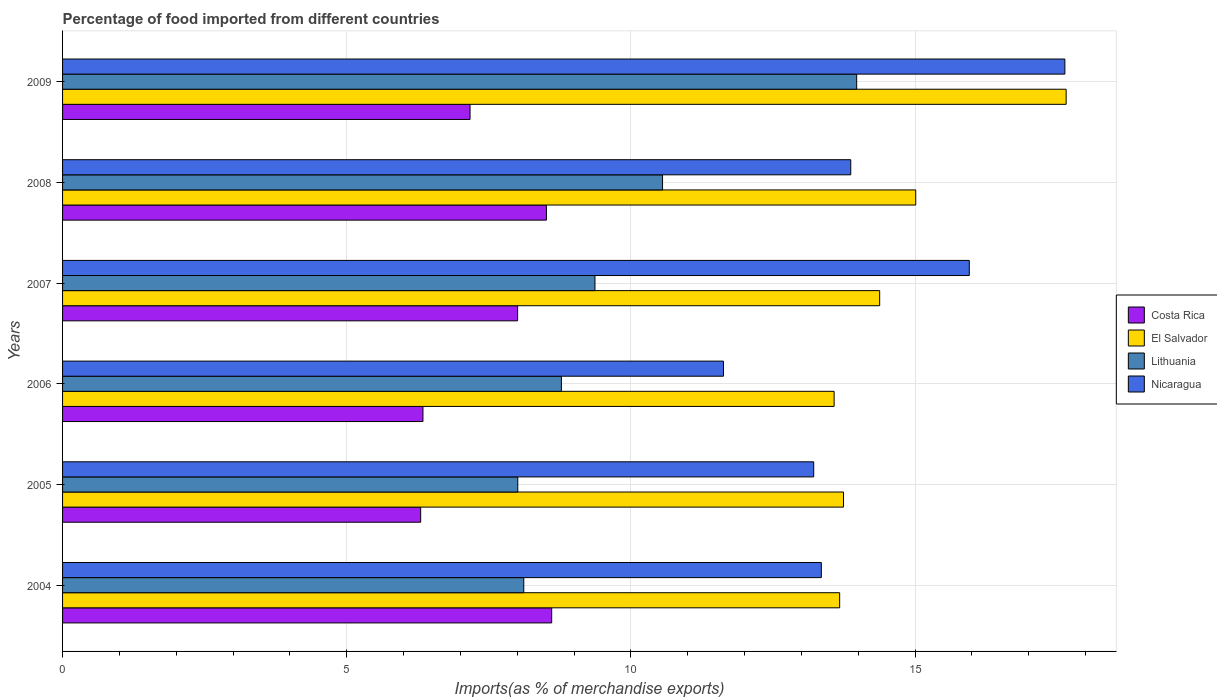Are the number of bars per tick equal to the number of legend labels?
Offer a very short reply. Yes. Are the number of bars on each tick of the Y-axis equal?
Offer a very short reply. Yes. How many bars are there on the 6th tick from the top?
Provide a succinct answer. 4. How many bars are there on the 1st tick from the bottom?
Offer a very short reply. 4. What is the percentage of imports to different countries in Costa Rica in 2008?
Make the answer very short. 8.51. Across all years, what is the maximum percentage of imports to different countries in Costa Rica?
Offer a terse response. 8.61. Across all years, what is the minimum percentage of imports to different countries in Lithuania?
Provide a short and direct response. 8.01. In which year was the percentage of imports to different countries in Lithuania minimum?
Keep it short and to the point. 2005. What is the total percentage of imports to different countries in Nicaragua in the graph?
Offer a terse response. 85.65. What is the difference between the percentage of imports to different countries in Lithuania in 2004 and that in 2006?
Offer a terse response. -0.66. What is the difference between the percentage of imports to different countries in Nicaragua in 2004 and the percentage of imports to different countries in El Salvador in 2009?
Make the answer very short. -4.31. What is the average percentage of imports to different countries in Lithuania per year?
Provide a succinct answer. 9.8. In the year 2005, what is the difference between the percentage of imports to different countries in Nicaragua and percentage of imports to different countries in Lithuania?
Provide a short and direct response. 5.21. What is the ratio of the percentage of imports to different countries in El Salvador in 2005 to that in 2007?
Your answer should be very brief. 0.96. Is the difference between the percentage of imports to different countries in Nicaragua in 2007 and 2009 greater than the difference between the percentage of imports to different countries in Lithuania in 2007 and 2009?
Provide a short and direct response. Yes. What is the difference between the highest and the second highest percentage of imports to different countries in Costa Rica?
Your answer should be very brief. 0.09. What is the difference between the highest and the lowest percentage of imports to different countries in El Salvador?
Give a very brief answer. 4.08. What does the 1st bar from the top in 2004 represents?
Offer a very short reply. Nicaragua. What does the 4th bar from the bottom in 2005 represents?
Make the answer very short. Nicaragua. Is it the case that in every year, the sum of the percentage of imports to different countries in Costa Rica and percentage of imports to different countries in El Salvador is greater than the percentage of imports to different countries in Lithuania?
Your answer should be very brief. Yes. How many bars are there?
Offer a terse response. 24. What is the difference between two consecutive major ticks on the X-axis?
Provide a succinct answer. 5. Does the graph contain any zero values?
Keep it short and to the point. No. Does the graph contain grids?
Keep it short and to the point. Yes. How many legend labels are there?
Your answer should be very brief. 4. How are the legend labels stacked?
Offer a terse response. Vertical. What is the title of the graph?
Give a very brief answer. Percentage of food imported from different countries. What is the label or title of the X-axis?
Ensure brevity in your answer.  Imports(as % of merchandise exports). What is the label or title of the Y-axis?
Your answer should be very brief. Years. What is the Imports(as % of merchandise exports) of Costa Rica in 2004?
Provide a short and direct response. 8.61. What is the Imports(as % of merchandise exports) in El Salvador in 2004?
Keep it short and to the point. 13.67. What is the Imports(as % of merchandise exports) in Lithuania in 2004?
Keep it short and to the point. 8.12. What is the Imports(as % of merchandise exports) in Nicaragua in 2004?
Provide a succinct answer. 13.35. What is the Imports(as % of merchandise exports) in Costa Rica in 2005?
Provide a succinct answer. 6.3. What is the Imports(as % of merchandise exports) in El Salvador in 2005?
Ensure brevity in your answer.  13.74. What is the Imports(as % of merchandise exports) in Lithuania in 2005?
Your answer should be very brief. 8.01. What is the Imports(as % of merchandise exports) in Nicaragua in 2005?
Offer a very short reply. 13.22. What is the Imports(as % of merchandise exports) of Costa Rica in 2006?
Ensure brevity in your answer.  6.34. What is the Imports(as % of merchandise exports) of El Salvador in 2006?
Make the answer very short. 13.58. What is the Imports(as % of merchandise exports) of Lithuania in 2006?
Provide a short and direct response. 8.78. What is the Imports(as % of merchandise exports) of Nicaragua in 2006?
Give a very brief answer. 11.63. What is the Imports(as % of merchandise exports) of Costa Rica in 2007?
Your response must be concise. 8.01. What is the Imports(as % of merchandise exports) in El Salvador in 2007?
Give a very brief answer. 14.38. What is the Imports(as % of merchandise exports) of Lithuania in 2007?
Offer a very short reply. 9.37. What is the Imports(as % of merchandise exports) in Nicaragua in 2007?
Make the answer very short. 15.95. What is the Imports(as % of merchandise exports) of Costa Rica in 2008?
Offer a terse response. 8.51. What is the Imports(as % of merchandise exports) in El Salvador in 2008?
Make the answer very short. 15.01. What is the Imports(as % of merchandise exports) of Lithuania in 2008?
Make the answer very short. 10.56. What is the Imports(as % of merchandise exports) of Nicaragua in 2008?
Offer a very short reply. 13.87. What is the Imports(as % of merchandise exports) in Costa Rica in 2009?
Offer a terse response. 7.17. What is the Imports(as % of merchandise exports) in El Salvador in 2009?
Your answer should be very brief. 17.66. What is the Imports(as % of merchandise exports) in Lithuania in 2009?
Your answer should be very brief. 13.97. What is the Imports(as % of merchandise exports) in Nicaragua in 2009?
Your response must be concise. 17.64. Across all years, what is the maximum Imports(as % of merchandise exports) in Costa Rica?
Offer a very short reply. 8.61. Across all years, what is the maximum Imports(as % of merchandise exports) in El Salvador?
Provide a short and direct response. 17.66. Across all years, what is the maximum Imports(as % of merchandise exports) of Lithuania?
Ensure brevity in your answer.  13.97. Across all years, what is the maximum Imports(as % of merchandise exports) of Nicaragua?
Make the answer very short. 17.64. Across all years, what is the minimum Imports(as % of merchandise exports) of Costa Rica?
Keep it short and to the point. 6.3. Across all years, what is the minimum Imports(as % of merchandise exports) in El Salvador?
Ensure brevity in your answer.  13.58. Across all years, what is the minimum Imports(as % of merchandise exports) in Lithuania?
Keep it short and to the point. 8.01. Across all years, what is the minimum Imports(as % of merchandise exports) of Nicaragua?
Provide a short and direct response. 11.63. What is the total Imports(as % of merchandise exports) of Costa Rica in the graph?
Your answer should be compact. 44.94. What is the total Imports(as % of merchandise exports) of El Salvador in the graph?
Provide a short and direct response. 88.04. What is the total Imports(as % of merchandise exports) of Lithuania in the graph?
Offer a terse response. 58.8. What is the total Imports(as % of merchandise exports) in Nicaragua in the graph?
Your response must be concise. 85.65. What is the difference between the Imports(as % of merchandise exports) in Costa Rica in 2004 and that in 2005?
Make the answer very short. 2.31. What is the difference between the Imports(as % of merchandise exports) in El Salvador in 2004 and that in 2005?
Your answer should be compact. -0.07. What is the difference between the Imports(as % of merchandise exports) in Lithuania in 2004 and that in 2005?
Offer a very short reply. 0.11. What is the difference between the Imports(as % of merchandise exports) of Nicaragua in 2004 and that in 2005?
Ensure brevity in your answer.  0.13. What is the difference between the Imports(as % of merchandise exports) of Costa Rica in 2004 and that in 2006?
Keep it short and to the point. 2.27. What is the difference between the Imports(as % of merchandise exports) in El Salvador in 2004 and that in 2006?
Keep it short and to the point. 0.1. What is the difference between the Imports(as % of merchandise exports) in Lithuania in 2004 and that in 2006?
Provide a short and direct response. -0.66. What is the difference between the Imports(as % of merchandise exports) of Nicaragua in 2004 and that in 2006?
Keep it short and to the point. 1.72. What is the difference between the Imports(as % of merchandise exports) of Costa Rica in 2004 and that in 2007?
Give a very brief answer. 0.6. What is the difference between the Imports(as % of merchandise exports) in El Salvador in 2004 and that in 2007?
Provide a succinct answer. -0.7. What is the difference between the Imports(as % of merchandise exports) in Lithuania in 2004 and that in 2007?
Ensure brevity in your answer.  -1.25. What is the difference between the Imports(as % of merchandise exports) of Nicaragua in 2004 and that in 2007?
Give a very brief answer. -2.6. What is the difference between the Imports(as % of merchandise exports) in Costa Rica in 2004 and that in 2008?
Provide a short and direct response. 0.09. What is the difference between the Imports(as % of merchandise exports) of El Salvador in 2004 and that in 2008?
Make the answer very short. -1.34. What is the difference between the Imports(as % of merchandise exports) of Lithuania in 2004 and that in 2008?
Your answer should be compact. -2.44. What is the difference between the Imports(as % of merchandise exports) in Nicaragua in 2004 and that in 2008?
Keep it short and to the point. -0.52. What is the difference between the Imports(as % of merchandise exports) in Costa Rica in 2004 and that in 2009?
Offer a very short reply. 1.44. What is the difference between the Imports(as % of merchandise exports) of El Salvador in 2004 and that in 2009?
Ensure brevity in your answer.  -3.99. What is the difference between the Imports(as % of merchandise exports) in Lithuania in 2004 and that in 2009?
Ensure brevity in your answer.  -5.86. What is the difference between the Imports(as % of merchandise exports) of Nicaragua in 2004 and that in 2009?
Give a very brief answer. -4.29. What is the difference between the Imports(as % of merchandise exports) of Costa Rica in 2005 and that in 2006?
Your response must be concise. -0.04. What is the difference between the Imports(as % of merchandise exports) of El Salvador in 2005 and that in 2006?
Your answer should be compact. 0.17. What is the difference between the Imports(as % of merchandise exports) of Lithuania in 2005 and that in 2006?
Your response must be concise. -0.77. What is the difference between the Imports(as % of merchandise exports) of Nicaragua in 2005 and that in 2006?
Give a very brief answer. 1.59. What is the difference between the Imports(as % of merchandise exports) of Costa Rica in 2005 and that in 2007?
Offer a terse response. -1.71. What is the difference between the Imports(as % of merchandise exports) in El Salvador in 2005 and that in 2007?
Your answer should be very brief. -0.64. What is the difference between the Imports(as % of merchandise exports) of Lithuania in 2005 and that in 2007?
Provide a short and direct response. -1.36. What is the difference between the Imports(as % of merchandise exports) in Nicaragua in 2005 and that in 2007?
Provide a succinct answer. -2.74. What is the difference between the Imports(as % of merchandise exports) of Costa Rica in 2005 and that in 2008?
Provide a succinct answer. -2.21. What is the difference between the Imports(as % of merchandise exports) of El Salvador in 2005 and that in 2008?
Provide a short and direct response. -1.27. What is the difference between the Imports(as % of merchandise exports) in Lithuania in 2005 and that in 2008?
Give a very brief answer. -2.55. What is the difference between the Imports(as % of merchandise exports) of Nicaragua in 2005 and that in 2008?
Make the answer very short. -0.65. What is the difference between the Imports(as % of merchandise exports) of Costa Rica in 2005 and that in 2009?
Keep it short and to the point. -0.87. What is the difference between the Imports(as % of merchandise exports) of El Salvador in 2005 and that in 2009?
Offer a very short reply. -3.92. What is the difference between the Imports(as % of merchandise exports) in Lithuania in 2005 and that in 2009?
Your answer should be compact. -5.96. What is the difference between the Imports(as % of merchandise exports) in Nicaragua in 2005 and that in 2009?
Keep it short and to the point. -4.42. What is the difference between the Imports(as % of merchandise exports) of Costa Rica in 2006 and that in 2007?
Ensure brevity in your answer.  -1.67. What is the difference between the Imports(as % of merchandise exports) in El Salvador in 2006 and that in 2007?
Give a very brief answer. -0.8. What is the difference between the Imports(as % of merchandise exports) in Lithuania in 2006 and that in 2007?
Give a very brief answer. -0.59. What is the difference between the Imports(as % of merchandise exports) in Nicaragua in 2006 and that in 2007?
Your answer should be very brief. -4.33. What is the difference between the Imports(as % of merchandise exports) in Costa Rica in 2006 and that in 2008?
Make the answer very short. -2.17. What is the difference between the Imports(as % of merchandise exports) of El Salvador in 2006 and that in 2008?
Keep it short and to the point. -1.44. What is the difference between the Imports(as % of merchandise exports) in Lithuania in 2006 and that in 2008?
Ensure brevity in your answer.  -1.78. What is the difference between the Imports(as % of merchandise exports) of Nicaragua in 2006 and that in 2008?
Your answer should be very brief. -2.24. What is the difference between the Imports(as % of merchandise exports) of Costa Rica in 2006 and that in 2009?
Your response must be concise. -0.83. What is the difference between the Imports(as % of merchandise exports) in El Salvador in 2006 and that in 2009?
Keep it short and to the point. -4.08. What is the difference between the Imports(as % of merchandise exports) in Lithuania in 2006 and that in 2009?
Ensure brevity in your answer.  -5.2. What is the difference between the Imports(as % of merchandise exports) of Nicaragua in 2006 and that in 2009?
Offer a terse response. -6.01. What is the difference between the Imports(as % of merchandise exports) in Costa Rica in 2007 and that in 2008?
Offer a very short reply. -0.51. What is the difference between the Imports(as % of merchandise exports) of El Salvador in 2007 and that in 2008?
Your answer should be very brief. -0.63. What is the difference between the Imports(as % of merchandise exports) in Lithuania in 2007 and that in 2008?
Your response must be concise. -1.19. What is the difference between the Imports(as % of merchandise exports) of Nicaragua in 2007 and that in 2008?
Give a very brief answer. 2.09. What is the difference between the Imports(as % of merchandise exports) in Costa Rica in 2007 and that in 2009?
Offer a very short reply. 0.84. What is the difference between the Imports(as % of merchandise exports) of El Salvador in 2007 and that in 2009?
Offer a very short reply. -3.28. What is the difference between the Imports(as % of merchandise exports) of Lithuania in 2007 and that in 2009?
Your response must be concise. -4.6. What is the difference between the Imports(as % of merchandise exports) in Nicaragua in 2007 and that in 2009?
Give a very brief answer. -1.68. What is the difference between the Imports(as % of merchandise exports) in Costa Rica in 2008 and that in 2009?
Your response must be concise. 1.34. What is the difference between the Imports(as % of merchandise exports) of El Salvador in 2008 and that in 2009?
Offer a terse response. -2.65. What is the difference between the Imports(as % of merchandise exports) in Lithuania in 2008 and that in 2009?
Ensure brevity in your answer.  -3.42. What is the difference between the Imports(as % of merchandise exports) of Nicaragua in 2008 and that in 2009?
Your answer should be very brief. -3.77. What is the difference between the Imports(as % of merchandise exports) of Costa Rica in 2004 and the Imports(as % of merchandise exports) of El Salvador in 2005?
Your answer should be compact. -5.13. What is the difference between the Imports(as % of merchandise exports) of Costa Rica in 2004 and the Imports(as % of merchandise exports) of Lithuania in 2005?
Your response must be concise. 0.6. What is the difference between the Imports(as % of merchandise exports) in Costa Rica in 2004 and the Imports(as % of merchandise exports) in Nicaragua in 2005?
Offer a terse response. -4.61. What is the difference between the Imports(as % of merchandise exports) in El Salvador in 2004 and the Imports(as % of merchandise exports) in Lithuania in 2005?
Offer a terse response. 5.66. What is the difference between the Imports(as % of merchandise exports) in El Salvador in 2004 and the Imports(as % of merchandise exports) in Nicaragua in 2005?
Your answer should be compact. 0.46. What is the difference between the Imports(as % of merchandise exports) of Lithuania in 2004 and the Imports(as % of merchandise exports) of Nicaragua in 2005?
Provide a short and direct response. -5.1. What is the difference between the Imports(as % of merchandise exports) of Costa Rica in 2004 and the Imports(as % of merchandise exports) of El Salvador in 2006?
Ensure brevity in your answer.  -4.97. What is the difference between the Imports(as % of merchandise exports) in Costa Rica in 2004 and the Imports(as % of merchandise exports) in Lithuania in 2006?
Ensure brevity in your answer.  -0.17. What is the difference between the Imports(as % of merchandise exports) in Costa Rica in 2004 and the Imports(as % of merchandise exports) in Nicaragua in 2006?
Give a very brief answer. -3.02. What is the difference between the Imports(as % of merchandise exports) of El Salvador in 2004 and the Imports(as % of merchandise exports) of Lithuania in 2006?
Offer a terse response. 4.9. What is the difference between the Imports(as % of merchandise exports) of El Salvador in 2004 and the Imports(as % of merchandise exports) of Nicaragua in 2006?
Make the answer very short. 2.04. What is the difference between the Imports(as % of merchandise exports) of Lithuania in 2004 and the Imports(as % of merchandise exports) of Nicaragua in 2006?
Offer a very short reply. -3.51. What is the difference between the Imports(as % of merchandise exports) of Costa Rica in 2004 and the Imports(as % of merchandise exports) of El Salvador in 2007?
Provide a succinct answer. -5.77. What is the difference between the Imports(as % of merchandise exports) in Costa Rica in 2004 and the Imports(as % of merchandise exports) in Lithuania in 2007?
Keep it short and to the point. -0.76. What is the difference between the Imports(as % of merchandise exports) of Costa Rica in 2004 and the Imports(as % of merchandise exports) of Nicaragua in 2007?
Give a very brief answer. -7.35. What is the difference between the Imports(as % of merchandise exports) of El Salvador in 2004 and the Imports(as % of merchandise exports) of Lithuania in 2007?
Make the answer very short. 4.31. What is the difference between the Imports(as % of merchandise exports) in El Salvador in 2004 and the Imports(as % of merchandise exports) in Nicaragua in 2007?
Provide a succinct answer. -2.28. What is the difference between the Imports(as % of merchandise exports) in Lithuania in 2004 and the Imports(as % of merchandise exports) in Nicaragua in 2007?
Your answer should be compact. -7.84. What is the difference between the Imports(as % of merchandise exports) of Costa Rica in 2004 and the Imports(as % of merchandise exports) of El Salvador in 2008?
Make the answer very short. -6.41. What is the difference between the Imports(as % of merchandise exports) in Costa Rica in 2004 and the Imports(as % of merchandise exports) in Lithuania in 2008?
Your response must be concise. -1.95. What is the difference between the Imports(as % of merchandise exports) of Costa Rica in 2004 and the Imports(as % of merchandise exports) of Nicaragua in 2008?
Offer a very short reply. -5.26. What is the difference between the Imports(as % of merchandise exports) of El Salvador in 2004 and the Imports(as % of merchandise exports) of Lithuania in 2008?
Ensure brevity in your answer.  3.12. What is the difference between the Imports(as % of merchandise exports) in El Salvador in 2004 and the Imports(as % of merchandise exports) in Nicaragua in 2008?
Your response must be concise. -0.2. What is the difference between the Imports(as % of merchandise exports) of Lithuania in 2004 and the Imports(as % of merchandise exports) of Nicaragua in 2008?
Make the answer very short. -5.75. What is the difference between the Imports(as % of merchandise exports) of Costa Rica in 2004 and the Imports(as % of merchandise exports) of El Salvador in 2009?
Provide a succinct answer. -9.05. What is the difference between the Imports(as % of merchandise exports) of Costa Rica in 2004 and the Imports(as % of merchandise exports) of Lithuania in 2009?
Provide a succinct answer. -5.37. What is the difference between the Imports(as % of merchandise exports) in Costa Rica in 2004 and the Imports(as % of merchandise exports) in Nicaragua in 2009?
Offer a very short reply. -9.03. What is the difference between the Imports(as % of merchandise exports) in El Salvador in 2004 and the Imports(as % of merchandise exports) in Lithuania in 2009?
Give a very brief answer. -0.3. What is the difference between the Imports(as % of merchandise exports) in El Salvador in 2004 and the Imports(as % of merchandise exports) in Nicaragua in 2009?
Your answer should be compact. -3.96. What is the difference between the Imports(as % of merchandise exports) of Lithuania in 2004 and the Imports(as % of merchandise exports) of Nicaragua in 2009?
Your answer should be very brief. -9.52. What is the difference between the Imports(as % of merchandise exports) in Costa Rica in 2005 and the Imports(as % of merchandise exports) in El Salvador in 2006?
Give a very brief answer. -7.27. What is the difference between the Imports(as % of merchandise exports) of Costa Rica in 2005 and the Imports(as % of merchandise exports) of Lithuania in 2006?
Your response must be concise. -2.48. What is the difference between the Imports(as % of merchandise exports) in Costa Rica in 2005 and the Imports(as % of merchandise exports) in Nicaragua in 2006?
Your answer should be very brief. -5.33. What is the difference between the Imports(as % of merchandise exports) of El Salvador in 2005 and the Imports(as % of merchandise exports) of Lithuania in 2006?
Give a very brief answer. 4.96. What is the difference between the Imports(as % of merchandise exports) in El Salvador in 2005 and the Imports(as % of merchandise exports) in Nicaragua in 2006?
Ensure brevity in your answer.  2.11. What is the difference between the Imports(as % of merchandise exports) in Lithuania in 2005 and the Imports(as % of merchandise exports) in Nicaragua in 2006?
Your answer should be very brief. -3.62. What is the difference between the Imports(as % of merchandise exports) of Costa Rica in 2005 and the Imports(as % of merchandise exports) of El Salvador in 2007?
Offer a very short reply. -8.08. What is the difference between the Imports(as % of merchandise exports) in Costa Rica in 2005 and the Imports(as % of merchandise exports) in Lithuania in 2007?
Ensure brevity in your answer.  -3.07. What is the difference between the Imports(as % of merchandise exports) in Costa Rica in 2005 and the Imports(as % of merchandise exports) in Nicaragua in 2007?
Offer a terse response. -9.65. What is the difference between the Imports(as % of merchandise exports) in El Salvador in 2005 and the Imports(as % of merchandise exports) in Lithuania in 2007?
Your answer should be compact. 4.37. What is the difference between the Imports(as % of merchandise exports) in El Salvador in 2005 and the Imports(as % of merchandise exports) in Nicaragua in 2007?
Keep it short and to the point. -2.21. What is the difference between the Imports(as % of merchandise exports) in Lithuania in 2005 and the Imports(as % of merchandise exports) in Nicaragua in 2007?
Offer a very short reply. -7.94. What is the difference between the Imports(as % of merchandise exports) of Costa Rica in 2005 and the Imports(as % of merchandise exports) of El Salvador in 2008?
Provide a short and direct response. -8.71. What is the difference between the Imports(as % of merchandise exports) in Costa Rica in 2005 and the Imports(as % of merchandise exports) in Lithuania in 2008?
Your response must be concise. -4.26. What is the difference between the Imports(as % of merchandise exports) of Costa Rica in 2005 and the Imports(as % of merchandise exports) of Nicaragua in 2008?
Your answer should be very brief. -7.57. What is the difference between the Imports(as % of merchandise exports) of El Salvador in 2005 and the Imports(as % of merchandise exports) of Lithuania in 2008?
Your response must be concise. 3.18. What is the difference between the Imports(as % of merchandise exports) in El Salvador in 2005 and the Imports(as % of merchandise exports) in Nicaragua in 2008?
Keep it short and to the point. -0.13. What is the difference between the Imports(as % of merchandise exports) in Lithuania in 2005 and the Imports(as % of merchandise exports) in Nicaragua in 2008?
Offer a very short reply. -5.86. What is the difference between the Imports(as % of merchandise exports) of Costa Rica in 2005 and the Imports(as % of merchandise exports) of El Salvador in 2009?
Ensure brevity in your answer.  -11.36. What is the difference between the Imports(as % of merchandise exports) of Costa Rica in 2005 and the Imports(as % of merchandise exports) of Lithuania in 2009?
Offer a very short reply. -7.67. What is the difference between the Imports(as % of merchandise exports) of Costa Rica in 2005 and the Imports(as % of merchandise exports) of Nicaragua in 2009?
Make the answer very short. -11.34. What is the difference between the Imports(as % of merchandise exports) in El Salvador in 2005 and the Imports(as % of merchandise exports) in Lithuania in 2009?
Your response must be concise. -0.23. What is the difference between the Imports(as % of merchandise exports) of El Salvador in 2005 and the Imports(as % of merchandise exports) of Nicaragua in 2009?
Give a very brief answer. -3.9. What is the difference between the Imports(as % of merchandise exports) of Lithuania in 2005 and the Imports(as % of merchandise exports) of Nicaragua in 2009?
Give a very brief answer. -9.63. What is the difference between the Imports(as % of merchandise exports) in Costa Rica in 2006 and the Imports(as % of merchandise exports) in El Salvador in 2007?
Your answer should be compact. -8.04. What is the difference between the Imports(as % of merchandise exports) of Costa Rica in 2006 and the Imports(as % of merchandise exports) of Lithuania in 2007?
Provide a succinct answer. -3.03. What is the difference between the Imports(as % of merchandise exports) of Costa Rica in 2006 and the Imports(as % of merchandise exports) of Nicaragua in 2007?
Keep it short and to the point. -9.61. What is the difference between the Imports(as % of merchandise exports) of El Salvador in 2006 and the Imports(as % of merchandise exports) of Lithuania in 2007?
Your response must be concise. 4.21. What is the difference between the Imports(as % of merchandise exports) in El Salvador in 2006 and the Imports(as % of merchandise exports) in Nicaragua in 2007?
Keep it short and to the point. -2.38. What is the difference between the Imports(as % of merchandise exports) in Lithuania in 2006 and the Imports(as % of merchandise exports) in Nicaragua in 2007?
Offer a terse response. -7.18. What is the difference between the Imports(as % of merchandise exports) in Costa Rica in 2006 and the Imports(as % of merchandise exports) in El Salvador in 2008?
Your response must be concise. -8.67. What is the difference between the Imports(as % of merchandise exports) of Costa Rica in 2006 and the Imports(as % of merchandise exports) of Lithuania in 2008?
Offer a very short reply. -4.22. What is the difference between the Imports(as % of merchandise exports) in Costa Rica in 2006 and the Imports(as % of merchandise exports) in Nicaragua in 2008?
Your answer should be very brief. -7.53. What is the difference between the Imports(as % of merchandise exports) of El Salvador in 2006 and the Imports(as % of merchandise exports) of Lithuania in 2008?
Offer a terse response. 3.02. What is the difference between the Imports(as % of merchandise exports) in El Salvador in 2006 and the Imports(as % of merchandise exports) in Nicaragua in 2008?
Provide a short and direct response. -0.29. What is the difference between the Imports(as % of merchandise exports) of Lithuania in 2006 and the Imports(as % of merchandise exports) of Nicaragua in 2008?
Your answer should be compact. -5.09. What is the difference between the Imports(as % of merchandise exports) in Costa Rica in 2006 and the Imports(as % of merchandise exports) in El Salvador in 2009?
Make the answer very short. -11.32. What is the difference between the Imports(as % of merchandise exports) in Costa Rica in 2006 and the Imports(as % of merchandise exports) in Lithuania in 2009?
Offer a very short reply. -7.63. What is the difference between the Imports(as % of merchandise exports) of Costa Rica in 2006 and the Imports(as % of merchandise exports) of Nicaragua in 2009?
Offer a terse response. -11.29. What is the difference between the Imports(as % of merchandise exports) in El Salvador in 2006 and the Imports(as % of merchandise exports) in Lithuania in 2009?
Your response must be concise. -0.4. What is the difference between the Imports(as % of merchandise exports) of El Salvador in 2006 and the Imports(as % of merchandise exports) of Nicaragua in 2009?
Ensure brevity in your answer.  -4.06. What is the difference between the Imports(as % of merchandise exports) in Lithuania in 2006 and the Imports(as % of merchandise exports) in Nicaragua in 2009?
Your response must be concise. -8.86. What is the difference between the Imports(as % of merchandise exports) in Costa Rica in 2007 and the Imports(as % of merchandise exports) in El Salvador in 2008?
Keep it short and to the point. -7.01. What is the difference between the Imports(as % of merchandise exports) of Costa Rica in 2007 and the Imports(as % of merchandise exports) of Lithuania in 2008?
Give a very brief answer. -2.55. What is the difference between the Imports(as % of merchandise exports) in Costa Rica in 2007 and the Imports(as % of merchandise exports) in Nicaragua in 2008?
Ensure brevity in your answer.  -5.86. What is the difference between the Imports(as % of merchandise exports) in El Salvador in 2007 and the Imports(as % of merchandise exports) in Lithuania in 2008?
Provide a succinct answer. 3.82. What is the difference between the Imports(as % of merchandise exports) of El Salvador in 2007 and the Imports(as % of merchandise exports) of Nicaragua in 2008?
Give a very brief answer. 0.51. What is the difference between the Imports(as % of merchandise exports) of Lithuania in 2007 and the Imports(as % of merchandise exports) of Nicaragua in 2008?
Offer a very short reply. -4.5. What is the difference between the Imports(as % of merchandise exports) in Costa Rica in 2007 and the Imports(as % of merchandise exports) in El Salvador in 2009?
Provide a short and direct response. -9.65. What is the difference between the Imports(as % of merchandise exports) of Costa Rica in 2007 and the Imports(as % of merchandise exports) of Lithuania in 2009?
Your answer should be compact. -5.97. What is the difference between the Imports(as % of merchandise exports) in Costa Rica in 2007 and the Imports(as % of merchandise exports) in Nicaragua in 2009?
Give a very brief answer. -9.63. What is the difference between the Imports(as % of merchandise exports) of El Salvador in 2007 and the Imports(as % of merchandise exports) of Lithuania in 2009?
Give a very brief answer. 0.4. What is the difference between the Imports(as % of merchandise exports) of El Salvador in 2007 and the Imports(as % of merchandise exports) of Nicaragua in 2009?
Your answer should be compact. -3.26. What is the difference between the Imports(as % of merchandise exports) in Lithuania in 2007 and the Imports(as % of merchandise exports) in Nicaragua in 2009?
Ensure brevity in your answer.  -8.27. What is the difference between the Imports(as % of merchandise exports) of Costa Rica in 2008 and the Imports(as % of merchandise exports) of El Salvador in 2009?
Your answer should be very brief. -9.14. What is the difference between the Imports(as % of merchandise exports) of Costa Rica in 2008 and the Imports(as % of merchandise exports) of Lithuania in 2009?
Provide a short and direct response. -5.46. What is the difference between the Imports(as % of merchandise exports) of Costa Rica in 2008 and the Imports(as % of merchandise exports) of Nicaragua in 2009?
Your answer should be compact. -9.12. What is the difference between the Imports(as % of merchandise exports) of El Salvador in 2008 and the Imports(as % of merchandise exports) of Lithuania in 2009?
Ensure brevity in your answer.  1.04. What is the difference between the Imports(as % of merchandise exports) in El Salvador in 2008 and the Imports(as % of merchandise exports) in Nicaragua in 2009?
Provide a short and direct response. -2.62. What is the difference between the Imports(as % of merchandise exports) in Lithuania in 2008 and the Imports(as % of merchandise exports) in Nicaragua in 2009?
Offer a terse response. -7.08. What is the average Imports(as % of merchandise exports) in Costa Rica per year?
Offer a terse response. 7.49. What is the average Imports(as % of merchandise exports) in El Salvador per year?
Keep it short and to the point. 14.67. What is the average Imports(as % of merchandise exports) of Lithuania per year?
Keep it short and to the point. 9.8. What is the average Imports(as % of merchandise exports) in Nicaragua per year?
Ensure brevity in your answer.  14.28. In the year 2004, what is the difference between the Imports(as % of merchandise exports) in Costa Rica and Imports(as % of merchandise exports) in El Salvador?
Your response must be concise. -5.07. In the year 2004, what is the difference between the Imports(as % of merchandise exports) of Costa Rica and Imports(as % of merchandise exports) of Lithuania?
Ensure brevity in your answer.  0.49. In the year 2004, what is the difference between the Imports(as % of merchandise exports) of Costa Rica and Imports(as % of merchandise exports) of Nicaragua?
Your answer should be compact. -4.74. In the year 2004, what is the difference between the Imports(as % of merchandise exports) of El Salvador and Imports(as % of merchandise exports) of Lithuania?
Make the answer very short. 5.56. In the year 2004, what is the difference between the Imports(as % of merchandise exports) in El Salvador and Imports(as % of merchandise exports) in Nicaragua?
Offer a terse response. 0.32. In the year 2004, what is the difference between the Imports(as % of merchandise exports) in Lithuania and Imports(as % of merchandise exports) in Nicaragua?
Ensure brevity in your answer.  -5.24. In the year 2005, what is the difference between the Imports(as % of merchandise exports) in Costa Rica and Imports(as % of merchandise exports) in El Salvador?
Your response must be concise. -7.44. In the year 2005, what is the difference between the Imports(as % of merchandise exports) in Costa Rica and Imports(as % of merchandise exports) in Lithuania?
Provide a succinct answer. -1.71. In the year 2005, what is the difference between the Imports(as % of merchandise exports) in Costa Rica and Imports(as % of merchandise exports) in Nicaragua?
Offer a very short reply. -6.92. In the year 2005, what is the difference between the Imports(as % of merchandise exports) in El Salvador and Imports(as % of merchandise exports) in Lithuania?
Give a very brief answer. 5.73. In the year 2005, what is the difference between the Imports(as % of merchandise exports) in El Salvador and Imports(as % of merchandise exports) in Nicaragua?
Provide a succinct answer. 0.52. In the year 2005, what is the difference between the Imports(as % of merchandise exports) of Lithuania and Imports(as % of merchandise exports) of Nicaragua?
Offer a terse response. -5.21. In the year 2006, what is the difference between the Imports(as % of merchandise exports) of Costa Rica and Imports(as % of merchandise exports) of El Salvador?
Keep it short and to the point. -7.23. In the year 2006, what is the difference between the Imports(as % of merchandise exports) of Costa Rica and Imports(as % of merchandise exports) of Lithuania?
Keep it short and to the point. -2.44. In the year 2006, what is the difference between the Imports(as % of merchandise exports) in Costa Rica and Imports(as % of merchandise exports) in Nicaragua?
Offer a very short reply. -5.29. In the year 2006, what is the difference between the Imports(as % of merchandise exports) of El Salvador and Imports(as % of merchandise exports) of Lithuania?
Ensure brevity in your answer.  4.8. In the year 2006, what is the difference between the Imports(as % of merchandise exports) in El Salvador and Imports(as % of merchandise exports) in Nicaragua?
Offer a very short reply. 1.95. In the year 2006, what is the difference between the Imports(as % of merchandise exports) of Lithuania and Imports(as % of merchandise exports) of Nicaragua?
Give a very brief answer. -2.85. In the year 2007, what is the difference between the Imports(as % of merchandise exports) of Costa Rica and Imports(as % of merchandise exports) of El Salvador?
Give a very brief answer. -6.37. In the year 2007, what is the difference between the Imports(as % of merchandise exports) of Costa Rica and Imports(as % of merchandise exports) of Lithuania?
Provide a succinct answer. -1.36. In the year 2007, what is the difference between the Imports(as % of merchandise exports) of Costa Rica and Imports(as % of merchandise exports) of Nicaragua?
Keep it short and to the point. -7.95. In the year 2007, what is the difference between the Imports(as % of merchandise exports) of El Salvador and Imports(as % of merchandise exports) of Lithuania?
Make the answer very short. 5.01. In the year 2007, what is the difference between the Imports(as % of merchandise exports) in El Salvador and Imports(as % of merchandise exports) in Nicaragua?
Make the answer very short. -1.58. In the year 2007, what is the difference between the Imports(as % of merchandise exports) in Lithuania and Imports(as % of merchandise exports) in Nicaragua?
Your answer should be compact. -6.59. In the year 2008, what is the difference between the Imports(as % of merchandise exports) in Costa Rica and Imports(as % of merchandise exports) in El Salvador?
Give a very brief answer. -6.5. In the year 2008, what is the difference between the Imports(as % of merchandise exports) in Costa Rica and Imports(as % of merchandise exports) in Lithuania?
Make the answer very short. -2.04. In the year 2008, what is the difference between the Imports(as % of merchandise exports) in Costa Rica and Imports(as % of merchandise exports) in Nicaragua?
Offer a very short reply. -5.35. In the year 2008, what is the difference between the Imports(as % of merchandise exports) of El Salvador and Imports(as % of merchandise exports) of Lithuania?
Your answer should be very brief. 4.46. In the year 2008, what is the difference between the Imports(as % of merchandise exports) in El Salvador and Imports(as % of merchandise exports) in Nicaragua?
Make the answer very short. 1.14. In the year 2008, what is the difference between the Imports(as % of merchandise exports) of Lithuania and Imports(as % of merchandise exports) of Nicaragua?
Your answer should be compact. -3.31. In the year 2009, what is the difference between the Imports(as % of merchandise exports) of Costa Rica and Imports(as % of merchandise exports) of El Salvador?
Keep it short and to the point. -10.49. In the year 2009, what is the difference between the Imports(as % of merchandise exports) of Costa Rica and Imports(as % of merchandise exports) of Lithuania?
Your answer should be very brief. -6.8. In the year 2009, what is the difference between the Imports(as % of merchandise exports) in Costa Rica and Imports(as % of merchandise exports) in Nicaragua?
Ensure brevity in your answer.  -10.47. In the year 2009, what is the difference between the Imports(as % of merchandise exports) of El Salvador and Imports(as % of merchandise exports) of Lithuania?
Offer a terse response. 3.69. In the year 2009, what is the difference between the Imports(as % of merchandise exports) in El Salvador and Imports(as % of merchandise exports) in Nicaragua?
Offer a terse response. 0.02. In the year 2009, what is the difference between the Imports(as % of merchandise exports) of Lithuania and Imports(as % of merchandise exports) of Nicaragua?
Offer a very short reply. -3.66. What is the ratio of the Imports(as % of merchandise exports) in Costa Rica in 2004 to that in 2005?
Your response must be concise. 1.37. What is the ratio of the Imports(as % of merchandise exports) in Lithuania in 2004 to that in 2005?
Ensure brevity in your answer.  1.01. What is the ratio of the Imports(as % of merchandise exports) of Nicaragua in 2004 to that in 2005?
Provide a short and direct response. 1.01. What is the ratio of the Imports(as % of merchandise exports) in Costa Rica in 2004 to that in 2006?
Provide a short and direct response. 1.36. What is the ratio of the Imports(as % of merchandise exports) in Lithuania in 2004 to that in 2006?
Ensure brevity in your answer.  0.92. What is the ratio of the Imports(as % of merchandise exports) in Nicaragua in 2004 to that in 2006?
Your response must be concise. 1.15. What is the ratio of the Imports(as % of merchandise exports) of Costa Rica in 2004 to that in 2007?
Provide a succinct answer. 1.07. What is the ratio of the Imports(as % of merchandise exports) in El Salvador in 2004 to that in 2007?
Make the answer very short. 0.95. What is the ratio of the Imports(as % of merchandise exports) in Lithuania in 2004 to that in 2007?
Keep it short and to the point. 0.87. What is the ratio of the Imports(as % of merchandise exports) in Nicaragua in 2004 to that in 2007?
Your answer should be compact. 0.84. What is the ratio of the Imports(as % of merchandise exports) of Costa Rica in 2004 to that in 2008?
Give a very brief answer. 1.01. What is the ratio of the Imports(as % of merchandise exports) in El Salvador in 2004 to that in 2008?
Make the answer very short. 0.91. What is the ratio of the Imports(as % of merchandise exports) in Lithuania in 2004 to that in 2008?
Offer a very short reply. 0.77. What is the ratio of the Imports(as % of merchandise exports) of Nicaragua in 2004 to that in 2008?
Your answer should be very brief. 0.96. What is the ratio of the Imports(as % of merchandise exports) in Costa Rica in 2004 to that in 2009?
Keep it short and to the point. 1.2. What is the ratio of the Imports(as % of merchandise exports) of El Salvador in 2004 to that in 2009?
Your response must be concise. 0.77. What is the ratio of the Imports(as % of merchandise exports) in Lithuania in 2004 to that in 2009?
Offer a terse response. 0.58. What is the ratio of the Imports(as % of merchandise exports) in Nicaragua in 2004 to that in 2009?
Offer a terse response. 0.76. What is the ratio of the Imports(as % of merchandise exports) in Costa Rica in 2005 to that in 2006?
Give a very brief answer. 0.99. What is the ratio of the Imports(as % of merchandise exports) of El Salvador in 2005 to that in 2006?
Your response must be concise. 1.01. What is the ratio of the Imports(as % of merchandise exports) in Lithuania in 2005 to that in 2006?
Your response must be concise. 0.91. What is the ratio of the Imports(as % of merchandise exports) of Nicaragua in 2005 to that in 2006?
Offer a terse response. 1.14. What is the ratio of the Imports(as % of merchandise exports) of Costa Rica in 2005 to that in 2007?
Your answer should be compact. 0.79. What is the ratio of the Imports(as % of merchandise exports) of El Salvador in 2005 to that in 2007?
Ensure brevity in your answer.  0.96. What is the ratio of the Imports(as % of merchandise exports) in Lithuania in 2005 to that in 2007?
Your response must be concise. 0.85. What is the ratio of the Imports(as % of merchandise exports) in Nicaragua in 2005 to that in 2007?
Offer a very short reply. 0.83. What is the ratio of the Imports(as % of merchandise exports) in Costa Rica in 2005 to that in 2008?
Your response must be concise. 0.74. What is the ratio of the Imports(as % of merchandise exports) of El Salvador in 2005 to that in 2008?
Provide a succinct answer. 0.92. What is the ratio of the Imports(as % of merchandise exports) of Lithuania in 2005 to that in 2008?
Offer a terse response. 0.76. What is the ratio of the Imports(as % of merchandise exports) of Nicaragua in 2005 to that in 2008?
Ensure brevity in your answer.  0.95. What is the ratio of the Imports(as % of merchandise exports) of Costa Rica in 2005 to that in 2009?
Offer a very short reply. 0.88. What is the ratio of the Imports(as % of merchandise exports) in El Salvador in 2005 to that in 2009?
Your response must be concise. 0.78. What is the ratio of the Imports(as % of merchandise exports) of Lithuania in 2005 to that in 2009?
Ensure brevity in your answer.  0.57. What is the ratio of the Imports(as % of merchandise exports) in Nicaragua in 2005 to that in 2009?
Make the answer very short. 0.75. What is the ratio of the Imports(as % of merchandise exports) in Costa Rica in 2006 to that in 2007?
Your response must be concise. 0.79. What is the ratio of the Imports(as % of merchandise exports) of El Salvador in 2006 to that in 2007?
Make the answer very short. 0.94. What is the ratio of the Imports(as % of merchandise exports) in Lithuania in 2006 to that in 2007?
Your answer should be compact. 0.94. What is the ratio of the Imports(as % of merchandise exports) in Nicaragua in 2006 to that in 2007?
Give a very brief answer. 0.73. What is the ratio of the Imports(as % of merchandise exports) of Costa Rica in 2006 to that in 2008?
Ensure brevity in your answer.  0.74. What is the ratio of the Imports(as % of merchandise exports) of El Salvador in 2006 to that in 2008?
Give a very brief answer. 0.9. What is the ratio of the Imports(as % of merchandise exports) in Lithuania in 2006 to that in 2008?
Your response must be concise. 0.83. What is the ratio of the Imports(as % of merchandise exports) of Nicaragua in 2006 to that in 2008?
Offer a very short reply. 0.84. What is the ratio of the Imports(as % of merchandise exports) in Costa Rica in 2006 to that in 2009?
Your response must be concise. 0.88. What is the ratio of the Imports(as % of merchandise exports) of El Salvador in 2006 to that in 2009?
Your answer should be very brief. 0.77. What is the ratio of the Imports(as % of merchandise exports) in Lithuania in 2006 to that in 2009?
Ensure brevity in your answer.  0.63. What is the ratio of the Imports(as % of merchandise exports) of Nicaragua in 2006 to that in 2009?
Your response must be concise. 0.66. What is the ratio of the Imports(as % of merchandise exports) in Costa Rica in 2007 to that in 2008?
Give a very brief answer. 0.94. What is the ratio of the Imports(as % of merchandise exports) in El Salvador in 2007 to that in 2008?
Give a very brief answer. 0.96. What is the ratio of the Imports(as % of merchandise exports) of Lithuania in 2007 to that in 2008?
Make the answer very short. 0.89. What is the ratio of the Imports(as % of merchandise exports) in Nicaragua in 2007 to that in 2008?
Offer a very short reply. 1.15. What is the ratio of the Imports(as % of merchandise exports) in Costa Rica in 2007 to that in 2009?
Give a very brief answer. 1.12. What is the ratio of the Imports(as % of merchandise exports) of El Salvador in 2007 to that in 2009?
Provide a succinct answer. 0.81. What is the ratio of the Imports(as % of merchandise exports) of Lithuania in 2007 to that in 2009?
Provide a succinct answer. 0.67. What is the ratio of the Imports(as % of merchandise exports) in Nicaragua in 2007 to that in 2009?
Keep it short and to the point. 0.9. What is the ratio of the Imports(as % of merchandise exports) of Costa Rica in 2008 to that in 2009?
Offer a terse response. 1.19. What is the ratio of the Imports(as % of merchandise exports) in El Salvador in 2008 to that in 2009?
Make the answer very short. 0.85. What is the ratio of the Imports(as % of merchandise exports) in Lithuania in 2008 to that in 2009?
Ensure brevity in your answer.  0.76. What is the ratio of the Imports(as % of merchandise exports) of Nicaragua in 2008 to that in 2009?
Make the answer very short. 0.79. What is the difference between the highest and the second highest Imports(as % of merchandise exports) of Costa Rica?
Make the answer very short. 0.09. What is the difference between the highest and the second highest Imports(as % of merchandise exports) of El Salvador?
Your answer should be very brief. 2.65. What is the difference between the highest and the second highest Imports(as % of merchandise exports) of Lithuania?
Offer a very short reply. 3.42. What is the difference between the highest and the second highest Imports(as % of merchandise exports) in Nicaragua?
Your response must be concise. 1.68. What is the difference between the highest and the lowest Imports(as % of merchandise exports) in Costa Rica?
Your answer should be compact. 2.31. What is the difference between the highest and the lowest Imports(as % of merchandise exports) in El Salvador?
Make the answer very short. 4.08. What is the difference between the highest and the lowest Imports(as % of merchandise exports) in Lithuania?
Your response must be concise. 5.96. What is the difference between the highest and the lowest Imports(as % of merchandise exports) of Nicaragua?
Keep it short and to the point. 6.01. 